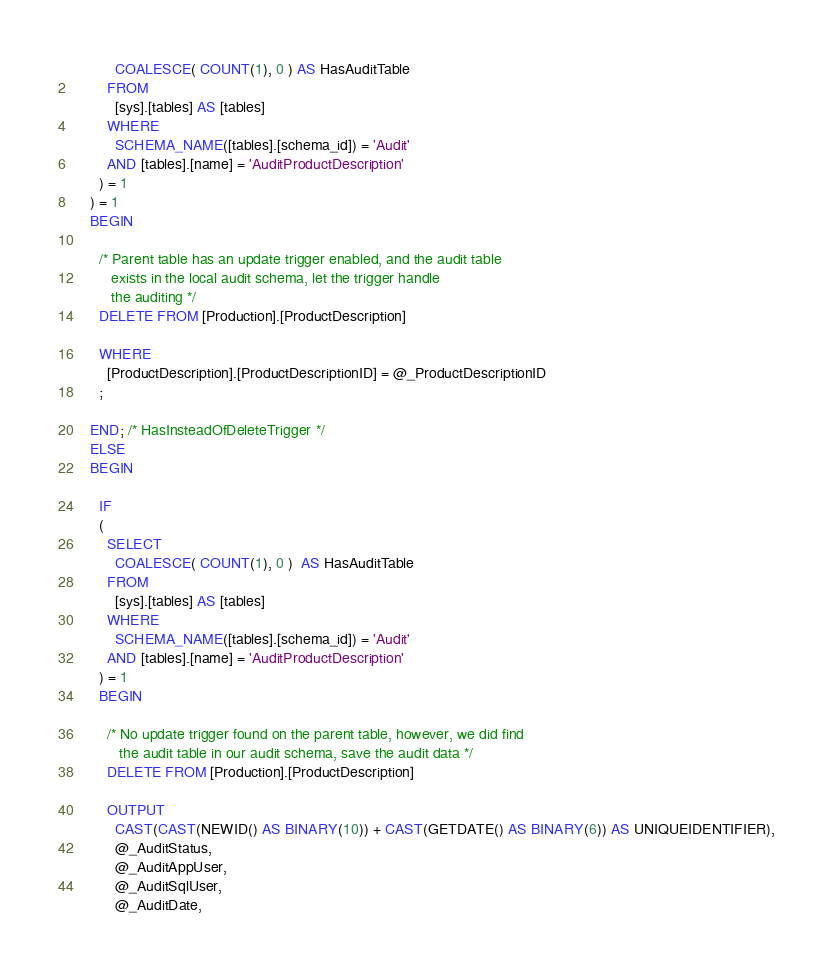Convert code to text. <code><loc_0><loc_0><loc_500><loc_500><_SQL_>          COALESCE( COUNT(1), 0 ) AS HasAuditTable
        FROM
          [sys].[tables] AS [tables]
        WHERE
          SCHEMA_NAME([tables].[schema_id]) = 'Audit'
        AND [tables].[name] = 'AuditProductDescription'
      ) = 1
    ) = 1
    BEGIN

      /* Parent table has an update trigger enabled, and the audit table
         exists in the local audit schema, let the trigger handle
         the auditing */
      DELETE FROM [Production].[ProductDescription]

      WHERE
        [ProductDescription].[ProductDescriptionID] = @_ProductDescriptionID
      ;

    END; /* HasInsteadOfDeleteTrigger */
    ELSE
    BEGIN

      IF
      (
        SELECT
          COALESCE( COUNT(1), 0 )  AS HasAuditTable
        FROM
          [sys].[tables] AS [tables]
        WHERE
          SCHEMA_NAME([tables].[schema_id]) = 'Audit'
        AND [tables].[name] = 'AuditProductDescription'
      ) = 1
      BEGIN

        /* No update trigger found on the parent table, however, we did find
           the audit table in our audit schema, save the audit data */
        DELETE FROM [Production].[ProductDescription]

        OUTPUT
          CAST(CAST(NEWID() AS BINARY(10)) + CAST(GETDATE() AS BINARY(6)) AS UNIQUEIDENTIFIER),
          @_AuditStatus,
          @_AuditAppUser,
          @_AuditSqlUser,
          @_AuditDate,</code> 